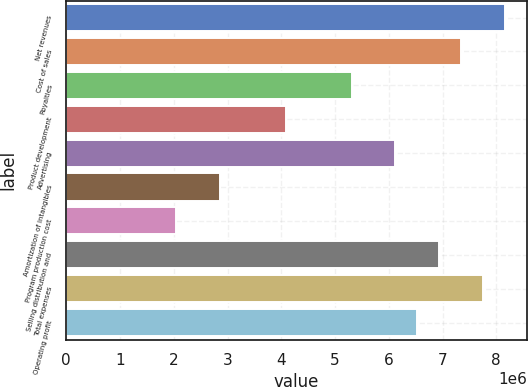Convert chart to OTSL. <chart><loc_0><loc_0><loc_500><loc_500><bar_chart><fcel>Net revenues<fcel>Cost of sales<fcel>Royalties<fcel>Product development<fcel>Advertising<fcel>Amortization of intangibles<fcel>Program production cost<fcel>Selling distribution and<fcel>Total expenses<fcel>Operating profit<nl><fcel>8.16431e+06<fcel>7.34788e+06<fcel>5.3068e+06<fcel>4.08216e+06<fcel>6.12323e+06<fcel>2.85751e+06<fcel>2.04108e+06<fcel>6.93967e+06<fcel>7.7561e+06<fcel>6.53145e+06<nl></chart> 